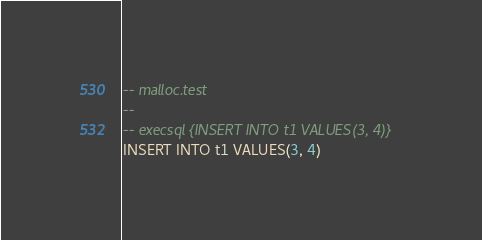<code> <loc_0><loc_0><loc_500><loc_500><_SQL_>-- malloc.test
-- 
-- execsql {INSERT INTO t1 VALUES(3, 4)}
INSERT INTO t1 VALUES(3, 4)</code> 